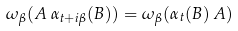Convert formula to latex. <formula><loc_0><loc_0><loc_500><loc_500>\omega _ { \beta } ( A \, \alpha _ { t + i \beta } ( B ) ) = \omega _ { \beta } ( \alpha _ { t } ( B ) \, A )</formula> 